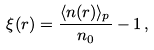<formula> <loc_0><loc_0><loc_500><loc_500>\xi ( r ) = \frac { \langle n ( r ) \rangle _ { p } } { n _ { 0 } } - 1 \, ,</formula> 